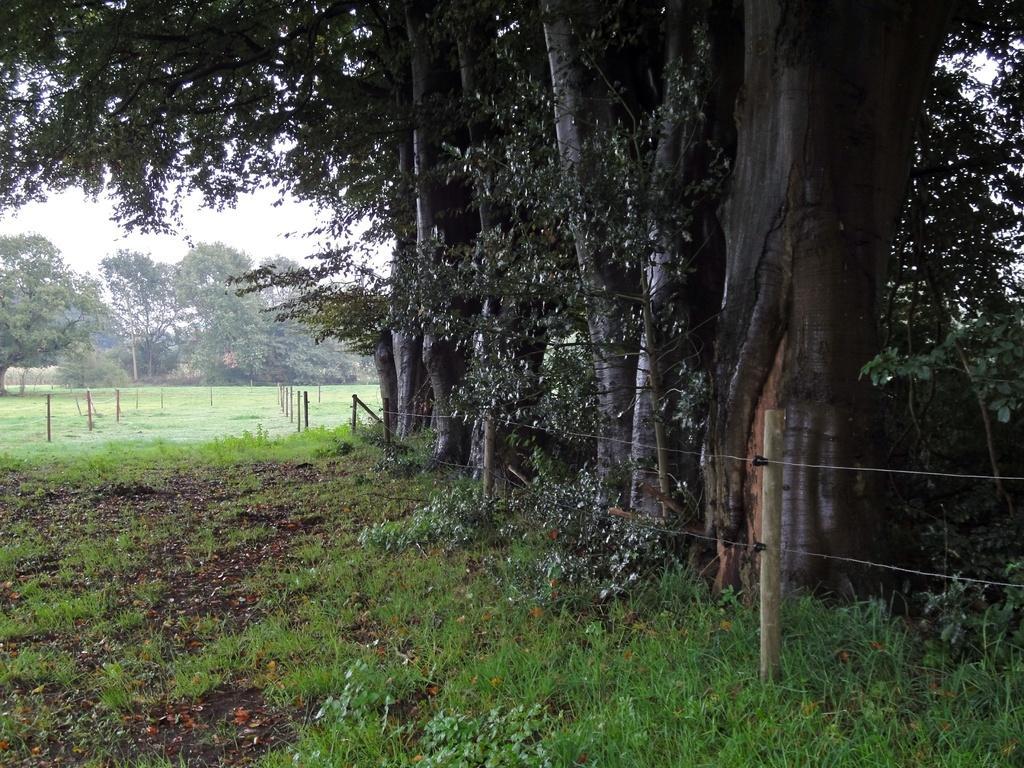In one or two sentences, can you explain what this image depicts? In this image I can see the ground, some grass on the ground, few wooden poles, the fencing and few trees which are green in color. In the background I can see the sky. 